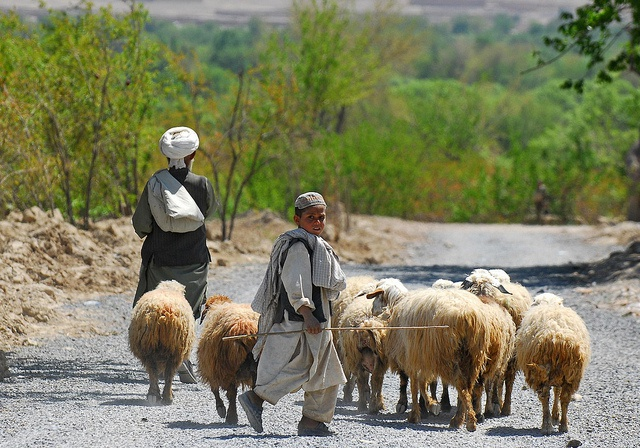Describe the objects in this image and their specific colors. I can see people in darkgray, gray, and black tones, sheep in darkgray, maroon, beige, and gray tones, people in darkgray, black, gray, and white tones, sheep in darkgray, maroon, beige, and tan tones, and sheep in darkgray, maroon, black, and gray tones in this image. 